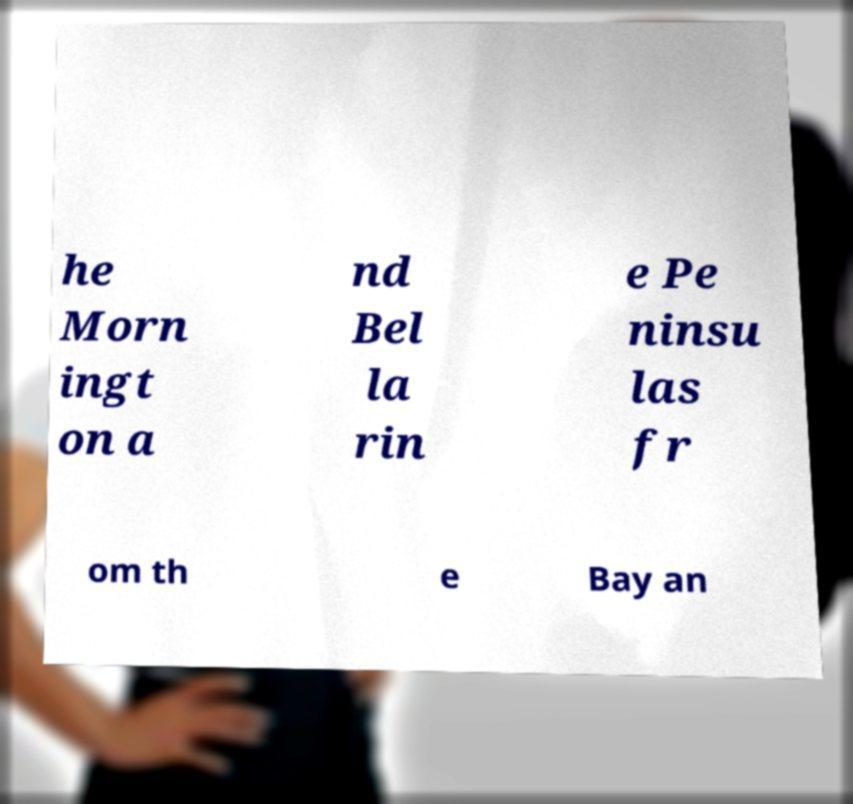There's text embedded in this image that I need extracted. Can you transcribe it verbatim? he Morn ingt on a nd Bel la rin e Pe ninsu las fr om th e Bay an 